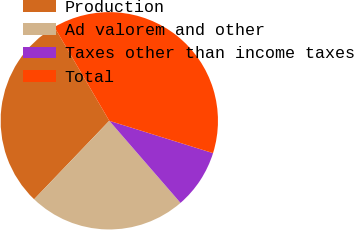Convert chart. <chart><loc_0><loc_0><loc_500><loc_500><pie_chart><fcel>Production<fcel>Ad valorem and other<fcel>Taxes other than income taxes<fcel>Total<nl><fcel>29.41%<fcel>23.53%<fcel>8.82%<fcel>38.24%<nl></chart> 